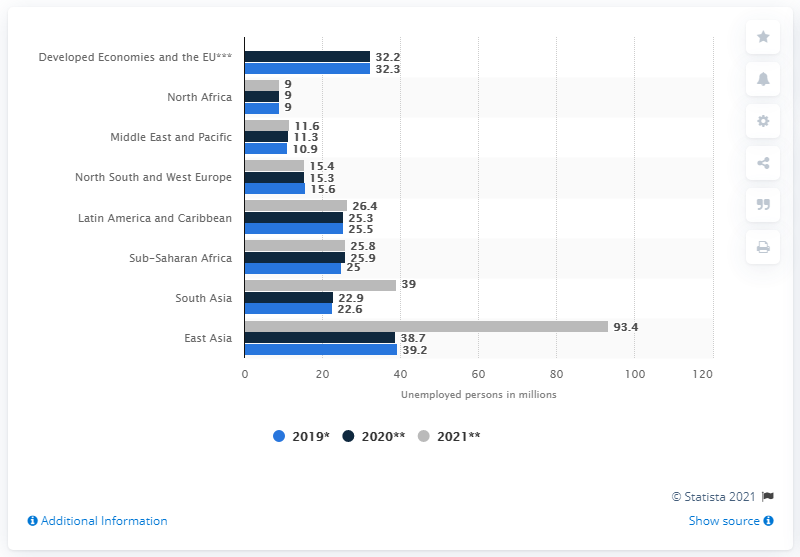Highlight a few significant elements in this photo. In 2021, it is projected that a significant number of people in the Middle East and Pacific region will be unemployed, estimated to be 11.6 million. 